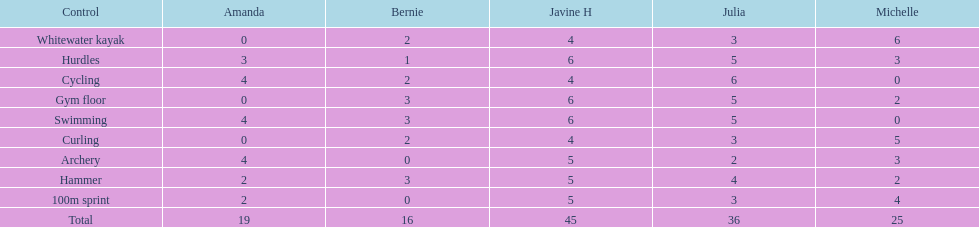List a girl who recorded the same score in both cycling and archery disciplines. Amanda. 